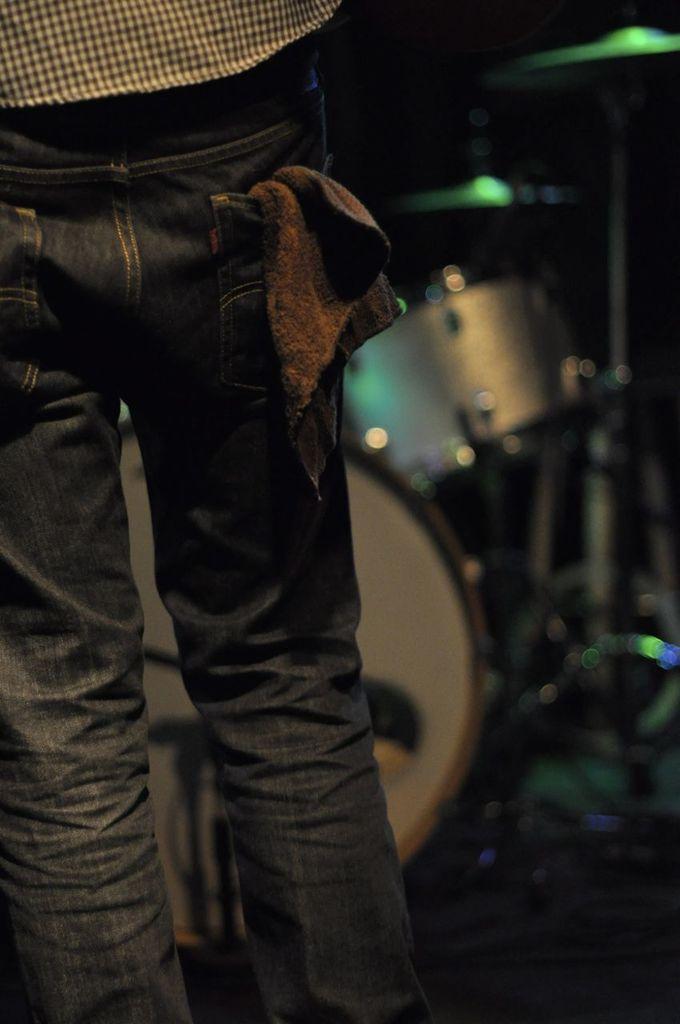Describe this image in one or two sentences. In this picture I can see a person is standing. The person is wearing a pant. In the background I can see musical instruments. 